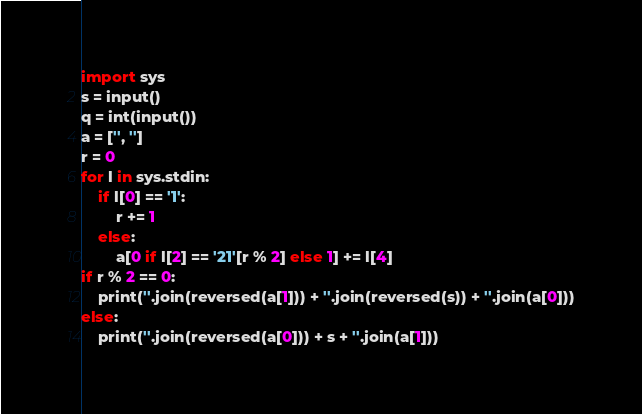<code> <loc_0><loc_0><loc_500><loc_500><_Python_>import sys
s = input()
q = int(input())
a = ['', '']
r = 0
for l in sys.stdin:
    if l[0] == '1':
        r += 1
    else:
        a[0 if l[2] == '21'[r % 2] else 1] += l[4]
if r % 2 == 0:
    print(''.join(reversed(a[1])) + ''.join(reversed(s)) + ''.join(a[0]))
else:
    print(''.join(reversed(a[0])) + s + ''.join(a[1]))</code> 